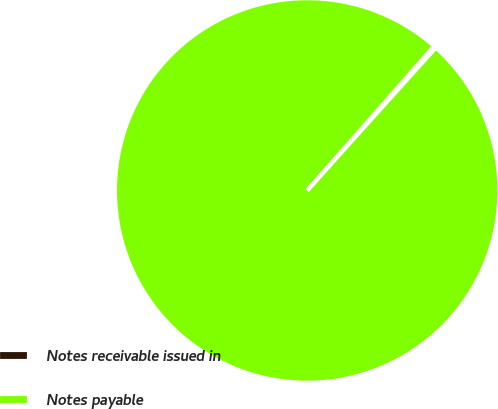Convert chart to OTSL. <chart><loc_0><loc_0><loc_500><loc_500><pie_chart><fcel>Notes receivable issued in<fcel>Notes payable<nl><fcel>0.2%<fcel>99.8%<nl></chart> 